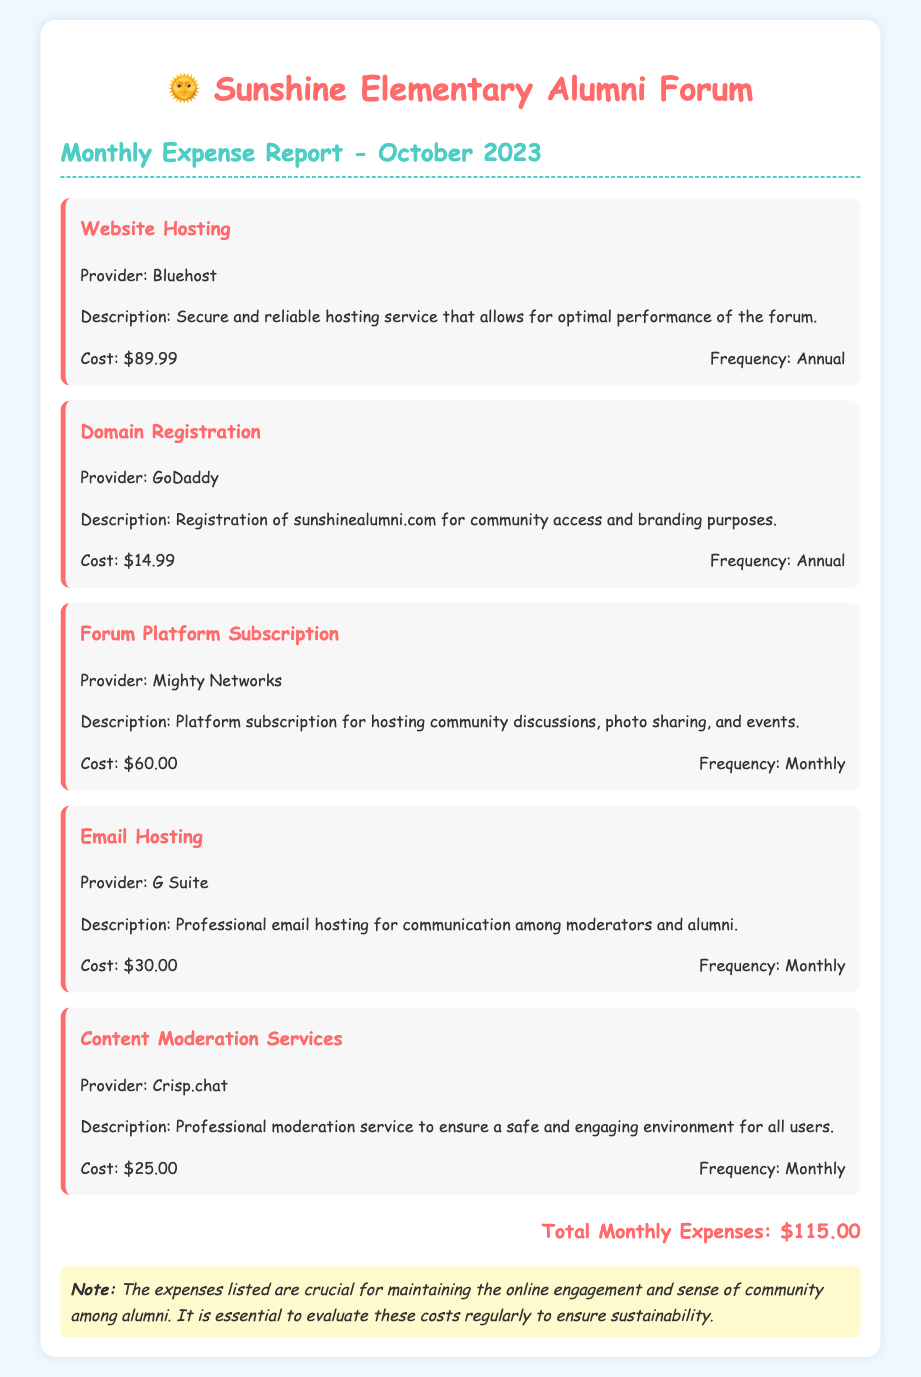What is the total monthly expense? The total monthly expense is provided at the end of the report, summing up all individual expenses listed.
Answer: $115.00 What is the cost of website hosting? The cost of website hosting is stated in the expense item for website hosting.
Answer: $89.99 What is the frequency of the Forum Platform Subscription? The frequency of the Forum Platform Subscription is mentioned in the expense item details.
Answer: Monthly Who is the provider for Email Hosting? The provider for Email Hosting is given in the description of the Email Hosting expense item.
Answer: G Suite How much does Domain Registration cost? The cost of Domain Registration is listed in the expense details for that item.
Answer: $14.99 What is the purpose of Content Moderation Services according to the report? The purpose of Content Moderation Services is described in the expense item details.
Answer: Safe and engaging environment How much do the monthly expenses for the forum platform and email hosting together amount to? This requires adding both monthly expenses: Forum Platform Subscription and Email Hosting costs.
Answer: $90.00 What type of document is this? This is a monthly expense report specifically detailing expenses related to forum maintenance.
Answer: Monthly Expense Report What is the registration service mentioned in the report? The registration service mentioned for domain registration is outlined within the relevant expense item.
Answer: GoDaddy 